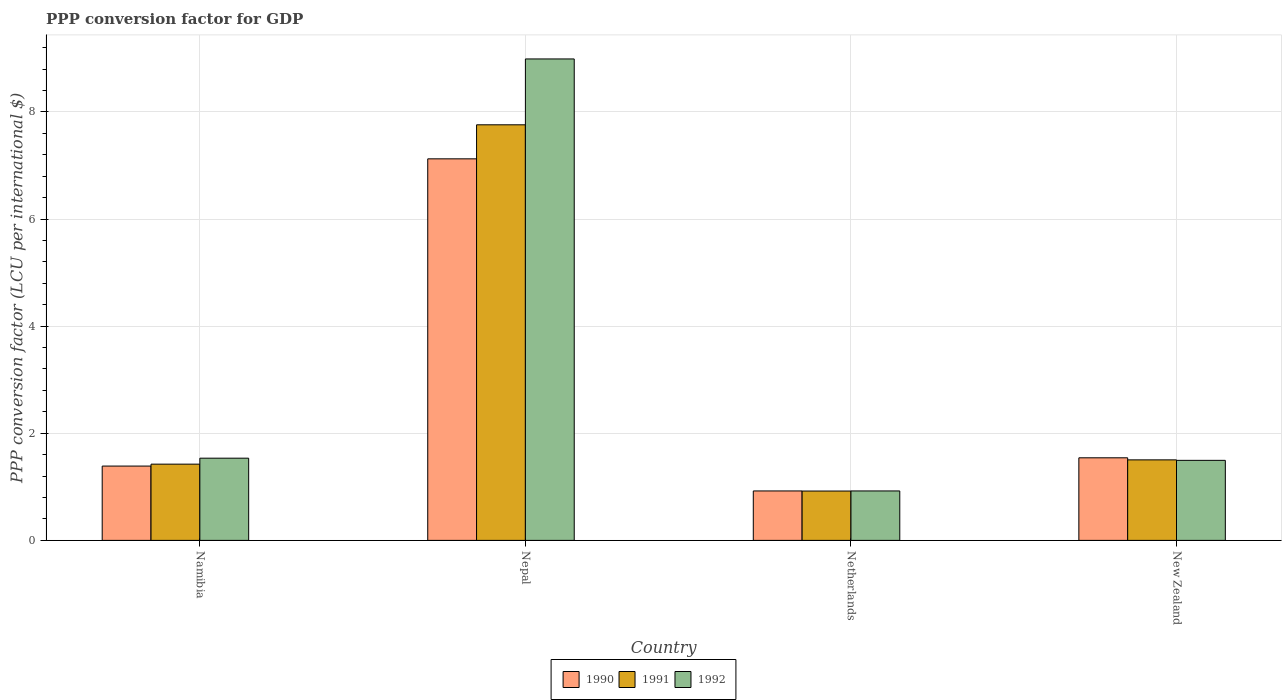How many different coloured bars are there?
Offer a very short reply. 3. How many groups of bars are there?
Ensure brevity in your answer.  4. What is the label of the 4th group of bars from the left?
Provide a short and direct response. New Zealand. In how many cases, is the number of bars for a given country not equal to the number of legend labels?
Keep it short and to the point. 0. What is the PPP conversion factor for GDP in 1991 in Namibia?
Your response must be concise. 1.42. Across all countries, what is the maximum PPP conversion factor for GDP in 1991?
Provide a succinct answer. 7.76. Across all countries, what is the minimum PPP conversion factor for GDP in 1991?
Your answer should be very brief. 0.92. In which country was the PPP conversion factor for GDP in 1990 maximum?
Keep it short and to the point. Nepal. What is the total PPP conversion factor for GDP in 1991 in the graph?
Provide a succinct answer. 11.61. What is the difference between the PPP conversion factor for GDP in 1991 in Nepal and that in Netherlands?
Ensure brevity in your answer.  6.84. What is the difference between the PPP conversion factor for GDP in 1991 in New Zealand and the PPP conversion factor for GDP in 1992 in Netherlands?
Offer a terse response. 0.58. What is the average PPP conversion factor for GDP in 1990 per country?
Ensure brevity in your answer.  2.74. What is the difference between the PPP conversion factor for GDP of/in 1992 and PPP conversion factor for GDP of/in 1990 in Nepal?
Your answer should be compact. 1.87. In how many countries, is the PPP conversion factor for GDP in 1991 greater than 2.4 LCU?
Your answer should be very brief. 1. What is the ratio of the PPP conversion factor for GDP in 1990 in Nepal to that in Netherlands?
Your response must be concise. 7.72. Is the PPP conversion factor for GDP in 1990 in Namibia less than that in Netherlands?
Your answer should be very brief. No. What is the difference between the highest and the second highest PPP conversion factor for GDP in 1992?
Provide a short and direct response. 7.45. What is the difference between the highest and the lowest PPP conversion factor for GDP in 1992?
Keep it short and to the point. 8.07. In how many countries, is the PPP conversion factor for GDP in 1992 greater than the average PPP conversion factor for GDP in 1992 taken over all countries?
Give a very brief answer. 1. What does the 2nd bar from the left in Nepal represents?
Give a very brief answer. 1991. How many bars are there?
Your answer should be compact. 12. How many countries are there in the graph?
Your response must be concise. 4. What is the difference between two consecutive major ticks on the Y-axis?
Provide a short and direct response. 2. Are the values on the major ticks of Y-axis written in scientific E-notation?
Make the answer very short. No. Where does the legend appear in the graph?
Ensure brevity in your answer.  Bottom center. How are the legend labels stacked?
Make the answer very short. Horizontal. What is the title of the graph?
Keep it short and to the point. PPP conversion factor for GDP. What is the label or title of the Y-axis?
Offer a very short reply. PPP conversion factor (LCU per international $). What is the PPP conversion factor (LCU per international $) of 1990 in Namibia?
Provide a short and direct response. 1.39. What is the PPP conversion factor (LCU per international $) in 1991 in Namibia?
Keep it short and to the point. 1.42. What is the PPP conversion factor (LCU per international $) of 1992 in Namibia?
Offer a terse response. 1.53. What is the PPP conversion factor (LCU per international $) in 1990 in Nepal?
Keep it short and to the point. 7.12. What is the PPP conversion factor (LCU per international $) in 1991 in Nepal?
Your answer should be compact. 7.76. What is the PPP conversion factor (LCU per international $) in 1992 in Nepal?
Provide a succinct answer. 8.99. What is the PPP conversion factor (LCU per international $) of 1990 in Netherlands?
Your response must be concise. 0.92. What is the PPP conversion factor (LCU per international $) in 1991 in Netherlands?
Your response must be concise. 0.92. What is the PPP conversion factor (LCU per international $) of 1992 in Netherlands?
Your response must be concise. 0.92. What is the PPP conversion factor (LCU per international $) in 1990 in New Zealand?
Provide a short and direct response. 1.54. What is the PPP conversion factor (LCU per international $) of 1991 in New Zealand?
Your answer should be very brief. 1.5. What is the PPP conversion factor (LCU per international $) in 1992 in New Zealand?
Your answer should be very brief. 1.49. Across all countries, what is the maximum PPP conversion factor (LCU per international $) in 1990?
Ensure brevity in your answer.  7.12. Across all countries, what is the maximum PPP conversion factor (LCU per international $) of 1991?
Ensure brevity in your answer.  7.76. Across all countries, what is the maximum PPP conversion factor (LCU per international $) in 1992?
Your answer should be compact. 8.99. Across all countries, what is the minimum PPP conversion factor (LCU per international $) in 1990?
Give a very brief answer. 0.92. Across all countries, what is the minimum PPP conversion factor (LCU per international $) of 1991?
Offer a very short reply. 0.92. Across all countries, what is the minimum PPP conversion factor (LCU per international $) in 1992?
Give a very brief answer. 0.92. What is the total PPP conversion factor (LCU per international $) of 1990 in the graph?
Keep it short and to the point. 10.98. What is the total PPP conversion factor (LCU per international $) of 1991 in the graph?
Provide a succinct answer. 11.61. What is the total PPP conversion factor (LCU per international $) of 1992 in the graph?
Provide a short and direct response. 12.94. What is the difference between the PPP conversion factor (LCU per international $) of 1990 in Namibia and that in Nepal?
Keep it short and to the point. -5.74. What is the difference between the PPP conversion factor (LCU per international $) of 1991 in Namibia and that in Nepal?
Give a very brief answer. -6.34. What is the difference between the PPP conversion factor (LCU per international $) in 1992 in Namibia and that in Nepal?
Keep it short and to the point. -7.45. What is the difference between the PPP conversion factor (LCU per international $) of 1990 in Namibia and that in Netherlands?
Your answer should be very brief. 0.46. What is the difference between the PPP conversion factor (LCU per international $) of 1991 in Namibia and that in Netherlands?
Your answer should be very brief. 0.5. What is the difference between the PPP conversion factor (LCU per international $) of 1992 in Namibia and that in Netherlands?
Your answer should be compact. 0.61. What is the difference between the PPP conversion factor (LCU per international $) of 1990 in Namibia and that in New Zealand?
Your answer should be very brief. -0.15. What is the difference between the PPP conversion factor (LCU per international $) in 1991 in Namibia and that in New Zealand?
Your response must be concise. -0.08. What is the difference between the PPP conversion factor (LCU per international $) in 1992 in Namibia and that in New Zealand?
Make the answer very short. 0.04. What is the difference between the PPP conversion factor (LCU per international $) in 1990 in Nepal and that in Netherlands?
Make the answer very short. 6.2. What is the difference between the PPP conversion factor (LCU per international $) in 1991 in Nepal and that in Netherlands?
Make the answer very short. 6.84. What is the difference between the PPP conversion factor (LCU per international $) of 1992 in Nepal and that in Netherlands?
Your answer should be compact. 8.07. What is the difference between the PPP conversion factor (LCU per international $) in 1990 in Nepal and that in New Zealand?
Provide a succinct answer. 5.58. What is the difference between the PPP conversion factor (LCU per international $) in 1991 in Nepal and that in New Zealand?
Give a very brief answer. 6.26. What is the difference between the PPP conversion factor (LCU per international $) in 1992 in Nepal and that in New Zealand?
Offer a very short reply. 7.49. What is the difference between the PPP conversion factor (LCU per international $) of 1990 in Netherlands and that in New Zealand?
Offer a terse response. -0.62. What is the difference between the PPP conversion factor (LCU per international $) in 1991 in Netherlands and that in New Zealand?
Your response must be concise. -0.58. What is the difference between the PPP conversion factor (LCU per international $) in 1992 in Netherlands and that in New Zealand?
Keep it short and to the point. -0.57. What is the difference between the PPP conversion factor (LCU per international $) in 1990 in Namibia and the PPP conversion factor (LCU per international $) in 1991 in Nepal?
Give a very brief answer. -6.37. What is the difference between the PPP conversion factor (LCU per international $) of 1990 in Namibia and the PPP conversion factor (LCU per international $) of 1992 in Nepal?
Provide a short and direct response. -7.6. What is the difference between the PPP conversion factor (LCU per international $) of 1991 in Namibia and the PPP conversion factor (LCU per international $) of 1992 in Nepal?
Provide a succinct answer. -7.57. What is the difference between the PPP conversion factor (LCU per international $) of 1990 in Namibia and the PPP conversion factor (LCU per international $) of 1991 in Netherlands?
Your answer should be compact. 0.47. What is the difference between the PPP conversion factor (LCU per international $) of 1990 in Namibia and the PPP conversion factor (LCU per international $) of 1992 in Netherlands?
Provide a succinct answer. 0.46. What is the difference between the PPP conversion factor (LCU per international $) in 1991 in Namibia and the PPP conversion factor (LCU per international $) in 1992 in Netherlands?
Provide a short and direct response. 0.5. What is the difference between the PPP conversion factor (LCU per international $) in 1990 in Namibia and the PPP conversion factor (LCU per international $) in 1991 in New Zealand?
Offer a terse response. -0.12. What is the difference between the PPP conversion factor (LCU per international $) of 1990 in Namibia and the PPP conversion factor (LCU per international $) of 1992 in New Zealand?
Keep it short and to the point. -0.11. What is the difference between the PPP conversion factor (LCU per international $) of 1991 in Namibia and the PPP conversion factor (LCU per international $) of 1992 in New Zealand?
Offer a very short reply. -0.07. What is the difference between the PPP conversion factor (LCU per international $) of 1990 in Nepal and the PPP conversion factor (LCU per international $) of 1991 in Netherlands?
Offer a very short reply. 6.2. What is the difference between the PPP conversion factor (LCU per international $) of 1990 in Nepal and the PPP conversion factor (LCU per international $) of 1992 in Netherlands?
Ensure brevity in your answer.  6.2. What is the difference between the PPP conversion factor (LCU per international $) in 1991 in Nepal and the PPP conversion factor (LCU per international $) in 1992 in Netherlands?
Your response must be concise. 6.84. What is the difference between the PPP conversion factor (LCU per international $) in 1990 in Nepal and the PPP conversion factor (LCU per international $) in 1991 in New Zealand?
Provide a succinct answer. 5.62. What is the difference between the PPP conversion factor (LCU per international $) in 1990 in Nepal and the PPP conversion factor (LCU per international $) in 1992 in New Zealand?
Provide a succinct answer. 5.63. What is the difference between the PPP conversion factor (LCU per international $) of 1991 in Nepal and the PPP conversion factor (LCU per international $) of 1992 in New Zealand?
Your answer should be compact. 6.26. What is the difference between the PPP conversion factor (LCU per international $) in 1990 in Netherlands and the PPP conversion factor (LCU per international $) in 1991 in New Zealand?
Your answer should be very brief. -0.58. What is the difference between the PPP conversion factor (LCU per international $) in 1990 in Netherlands and the PPP conversion factor (LCU per international $) in 1992 in New Zealand?
Offer a terse response. -0.57. What is the difference between the PPP conversion factor (LCU per international $) of 1991 in Netherlands and the PPP conversion factor (LCU per international $) of 1992 in New Zealand?
Ensure brevity in your answer.  -0.57. What is the average PPP conversion factor (LCU per international $) in 1990 per country?
Ensure brevity in your answer.  2.74. What is the average PPP conversion factor (LCU per international $) of 1991 per country?
Offer a very short reply. 2.9. What is the average PPP conversion factor (LCU per international $) of 1992 per country?
Give a very brief answer. 3.24. What is the difference between the PPP conversion factor (LCU per international $) in 1990 and PPP conversion factor (LCU per international $) in 1991 in Namibia?
Offer a very short reply. -0.04. What is the difference between the PPP conversion factor (LCU per international $) of 1990 and PPP conversion factor (LCU per international $) of 1992 in Namibia?
Provide a succinct answer. -0.15. What is the difference between the PPP conversion factor (LCU per international $) in 1991 and PPP conversion factor (LCU per international $) in 1992 in Namibia?
Your answer should be compact. -0.11. What is the difference between the PPP conversion factor (LCU per international $) in 1990 and PPP conversion factor (LCU per international $) in 1991 in Nepal?
Your answer should be compact. -0.64. What is the difference between the PPP conversion factor (LCU per international $) in 1990 and PPP conversion factor (LCU per international $) in 1992 in Nepal?
Provide a succinct answer. -1.87. What is the difference between the PPP conversion factor (LCU per international $) in 1991 and PPP conversion factor (LCU per international $) in 1992 in Nepal?
Offer a terse response. -1.23. What is the difference between the PPP conversion factor (LCU per international $) of 1990 and PPP conversion factor (LCU per international $) of 1991 in Netherlands?
Your response must be concise. 0. What is the difference between the PPP conversion factor (LCU per international $) in 1990 and PPP conversion factor (LCU per international $) in 1992 in Netherlands?
Make the answer very short. -0. What is the difference between the PPP conversion factor (LCU per international $) in 1991 and PPP conversion factor (LCU per international $) in 1992 in Netherlands?
Offer a terse response. -0. What is the difference between the PPP conversion factor (LCU per international $) in 1990 and PPP conversion factor (LCU per international $) in 1991 in New Zealand?
Keep it short and to the point. 0.04. What is the difference between the PPP conversion factor (LCU per international $) of 1990 and PPP conversion factor (LCU per international $) of 1992 in New Zealand?
Your response must be concise. 0.05. What is the difference between the PPP conversion factor (LCU per international $) of 1991 and PPP conversion factor (LCU per international $) of 1992 in New Zealand?
Your response must be concise. 0.01. What is the ratio of the PPP conversion factor (LCU per international $) of 1990 in Namibia to that in Nepal?
Your answer should be compact. 0.19. What is the ratio of the PPP conversion factor (LCU per international $) in 1991 in Namibia to that in Nepal?
Your answer should be compact. 0.18. What is the ratio of the PPP conversion factor (LCU per international $) of 1992 in Namibia to that in Nepal?
Your response must be concise. 0.17. What is the ratio of the PPP conversion factor (LCU per international $) of 1990 in Namibia to that in Netherlands?
Provide a succinct answer. 1.5. What is the ratio of the PPP conversion factor (LCU per international $) in 1991 in Namibia to that in Netherlands?
Your response must be concise. 1.54. What is the ratio of the PPP conversion factor (LCU per international $) in 1992 in Namibia to that in Netherlands?
Provide a succinct answer. 1.66. What is the ratio of the PPP conversion factor (LCU per international $) in 1990 in Namibia to that in New Zealand?
Offer a very short reply. 0.9. What is the ratio of the PPP conversion factor (LCU per international $) of 1991 in Namibia to that in New Zealand?
Your response must be concise. 0.95. What is the ratio of the PPP conversion factor (LCU per international $) of 1992 in Namibia to that in New Zealand?
Your answer should be compact. 1.03. What is the ratio of the PPP conversion factor (LCU per international $) of 1990 in Nepal to that in Netherlands?
Offer a terse response. 7.72. What is the ratio of the PPP conversion factor (LCU per international $) of 1991 in Nepal to that in Netherlands?
Your answer should be compact. 8.42. What is the ratio of the PPP conversion factor (LCU per international $) in 1992 in Nepal to that in Netherlands?
Your answer should be very brief. 9.74. What is the ratio of the PPP conversion factor (LCU per international $) in 1990 in Nepal to that in New Zealand?
Give a very brief answer. 4.62. What is the ratio of the PPP conversion factor (LCU per international $) in 1991 in Nepal to that in New Zealand?
Keep it short and to the point. 5.16. What is the ratio of the PPP conversion factor (LCU per international $) in 1992 in Nepal to that in New Zealand?
Your response must be concise. 6.02. What is the ratio of the PPP conversion factor (LCU per international $) of 1990 in Netherlands to that in New Zealand?
Your answer should be compact. 0.6. What is the ratio of the PPP conversion factor (LCU per international $) of 1991 in Netherlands to that in New Zealand?
Provide a succinct answer. 0.61. What is the ratio of the PPP conversion factor (LCU per international $) of 1992 in Netherlands to that in New Zealand?
Offer a very short reply. 0.62. What is the difference between the highest and the second highest PPP conversion factor (LCU per international $) of 1990?
Give a very brief answer. 5.58. What is the difference between the highest and the second highest PPP conversion factor (LCU per international $) of 1991?
Offer a terse response. 6.26. What is the difference between the highest and the second highest PPP conversion factor (LCU per international $) in 1992?
Your answer should be very brief. 7.45. What is the difference between the highest and the lowest PPP conversion factor (LCU per international $) in 1990?
Make the answer very short. 6.2. What is the difference between the highest and the lowest PPP conversion factor (LCU per international $) in 1991?
Provide a succinct answer. 6.84. What is the difference between the highest and the lowest PPP conversion factor (LCU per international $) of 1992?
Ensure brevity in your answer.  8.07. 